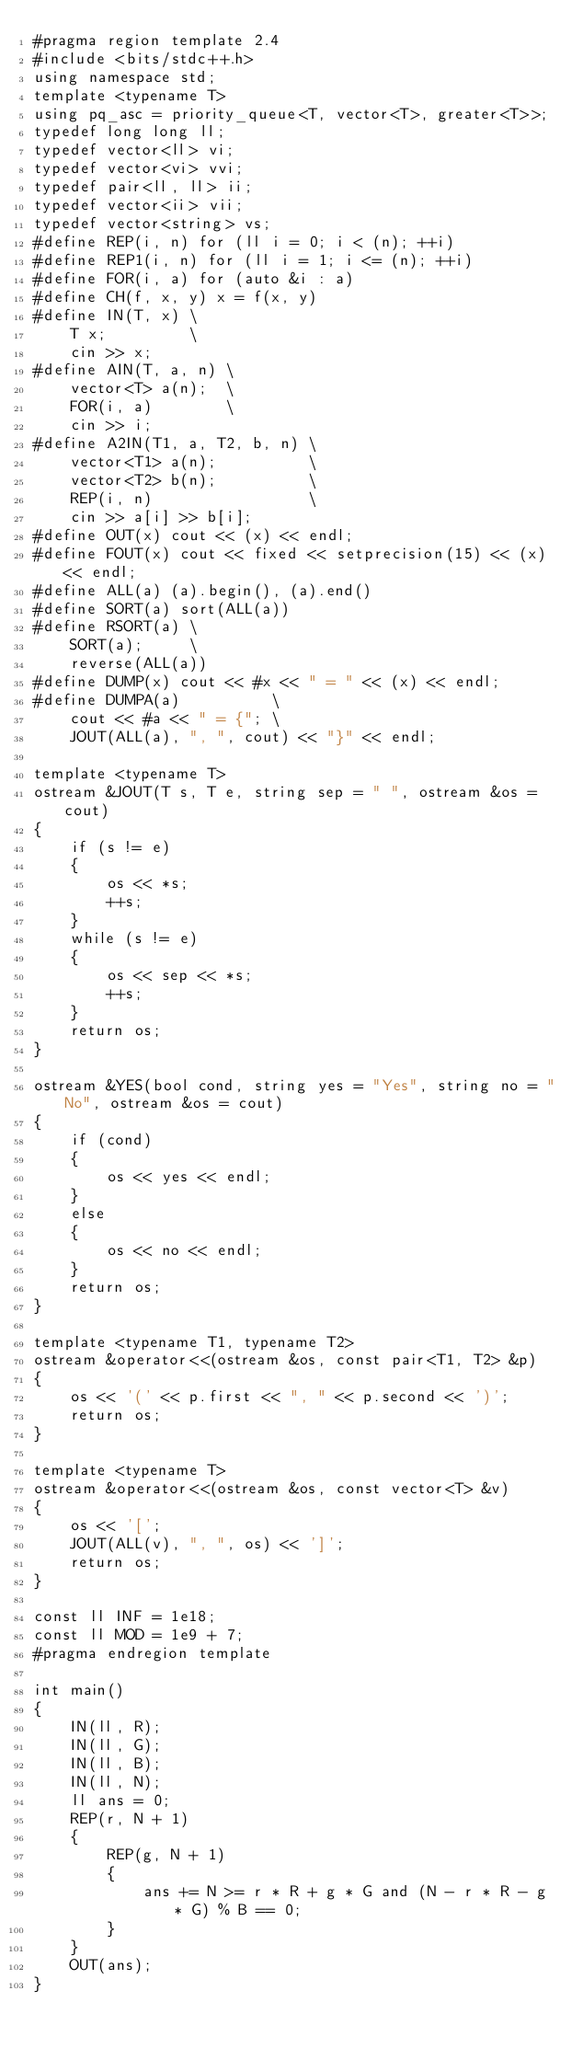Convert code to text. <code><loc_0><loc_0><loc_500><loc_500><_C++_>#pragma region template 2.4
#include <bits/stdc++.h>
using namespace std;
template <typename T>
using pq_asc = priority_queue<T, vector<T>, greater<T>>;
typedef long long ll;
typedef vector<ll> vi;
typedef vector<vi> vvi;
typedef pair<ll, ll> ii;
typedef vector<ii> vii;
typedef vector<string> vs;
#define REP(i, n) for (ll i = 0; i < (n); ++i)
#define REP1(i, n) for (ll i = 1; i <= (n); ++i)
#define FOR(i, a) for (auto &i : a)
#define CH(f, x, y) x = f(x, y)
#define IN(T, x) \
    T x;         \
    cin >> x;
#define AIN(T, a, n) \
    vector<T> a(n);  \
    FOR(i, a)        \
    cin >> i;
#define A2IN(T1, a, T2, b, n) \
    vector<T1> a(n);          \
    vector<T2> b(n);          \
    REP(i, n)                 \
    cin >> a[i] >> b[i];
#define OUT(x) cout << (x) << endl;
#define FOUT(x) cout << fixed << setprecision(15) << (x) << endl;
#define ALL(a) (a).begin(), (a).end()
#define SORT(a) sort(ALL(a))
#define RSORT(a) \
    SORT(a);     \
    reverse(ALL(a))
#define DUMP(x) cout << #x << " = " << (x) << endl;
#define DUMPA(a)          \
    cout << #a << " = {"; \
    JOUT(ALL(a), ", ", cout) << "}" << endl;

template <typename T>
ostream &JOUT(T s, T e, string sep = " ", ostream &os = cout)
{
    if (s != e)
    {
        os << *s;
        ++s;
    }
    while (s != e)
    {
        os << sep << *s;
        ++s;
    }
    return os;
}

ostream &YES(bool cond, string yes = "Yes", string no = "No", ostream &os = cout)
{
    if (cond)
    {
        os << yes << endl;
    }
    else
    {
        os << no << endl;
    }
    return os;
}

template <typename T1, typename T2>
ostream &operator<<(ostream &os, const pair<T1, T2> &p)
{
    os << '(' << p.first << ", " << p.second << ')';
    return os;
}

template <typename T>
ostream &operator<<(ostream &os, const vector<T> &v)
{
    os << '[';
    JOUT(ALL(v), ", ", os) << ']';
    return os;
}

const ll INF = 1e18;
const ll MOD = 1e9 + 7;
#pragma endregion template

int main()
{
    IN(ll, R);
    IN(ll, G);
    IN(ll, B);
    IN(ll, N);
    ll ans = 0;
    REP(r, N + 1)
    {
        REP(g, N + 1)
        {
            ans += N >= r * R + g * G and (N - r * R - g * G) % B == 0;
        }
    }
    OUT(ans);
}</code> 